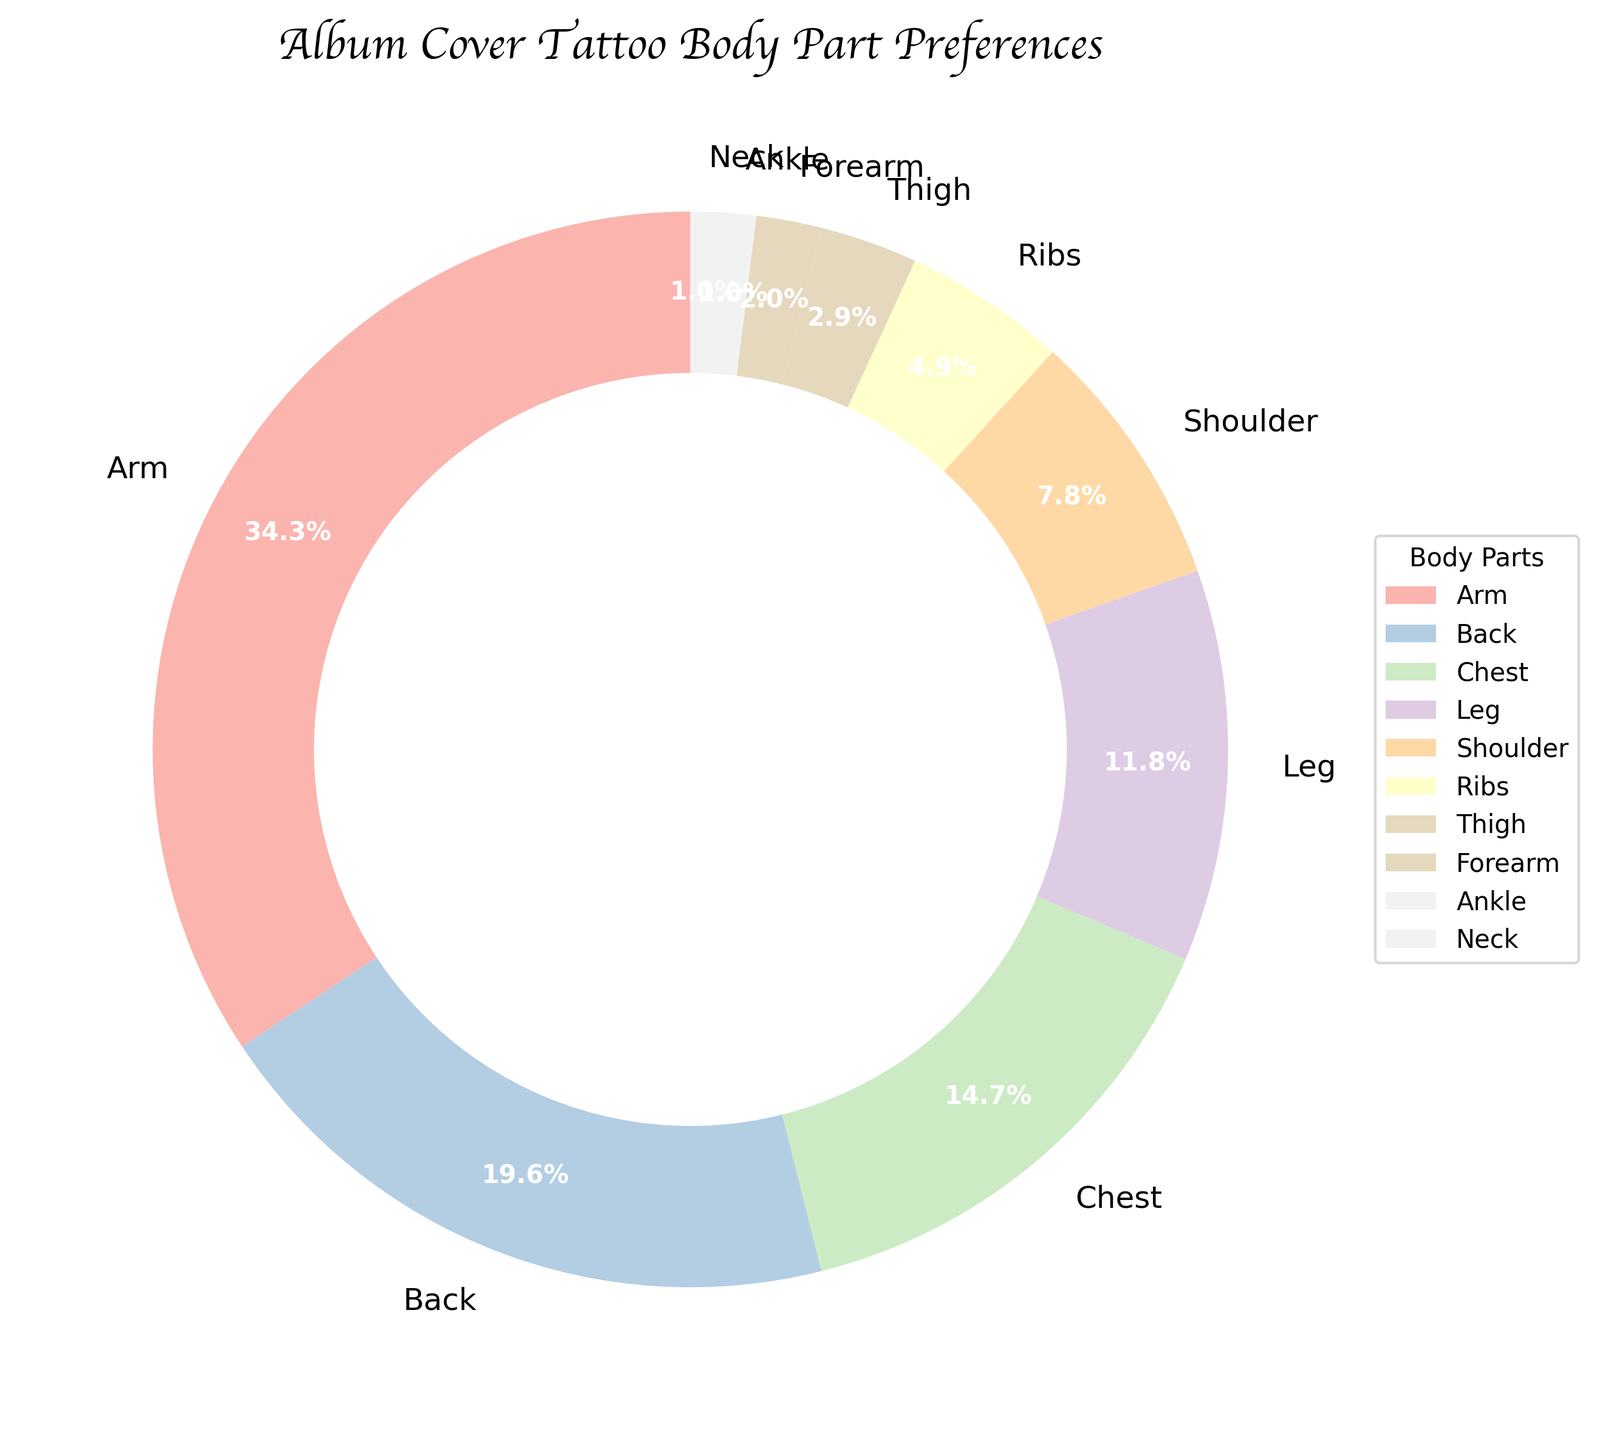What body part is chosen the most for album cover tattoos? The largest wedge in the pie chart represents the arm, which has the highest percentage at 35%.
Answer: Arm Which two body parts have the closest percentage values? Observing the pie chart, the shoulder (8%) and ribs (5%) have the closest percentage values with a difference of only 3%.
Answer: Shoulder and Ribs What percentage of tattoos are placed on the leg and thigh combined? Adding the percentages for the leg (12%) and thigh (3%), the combined percentage is 15%.
Answer: 15% How many body parts have a tattoo percentage less than or equal to 5%? By examining the chart, ribs (5%), thigh (3%), forearm (2%), ankle (1%), and neck (1%) are all less than or equal to 5%. There are 5 such parts.
Answer: 5 Is the percentage of tattoos on the back greater than on the chest? Yes, the back has a percentage of 20%, which is greater than the chest at 15%.
Answer: Yes Which three body parts have the smallest percentages, and what are their combined percentage? The smallest percentages are for the neck (1%), ankle (1%), and forearm (2%). Combining these gives 1% + 1% + 2% = 4%.
Answer: Neck, Ankle, and Forearm; 4% How does the percentage of tattoos on the shoulder compare to those on the chest? The shoulder has 8% while the chest has 15%. Therefore, the chest has a higher percentage than the shoulder.
Answer: Chest is higher What is the difference in percentage between tattoos on the arm and the leg? Subtracting the percentage of the leg (12%) from the arm (35%) gives 35% - 12% = 23%.
Answer: 23% Are there more tattoos on the back or the leg? By looking at the pie chart, the back has a higher percentage (20%) compared to the leg (12%).
Answer: Back 